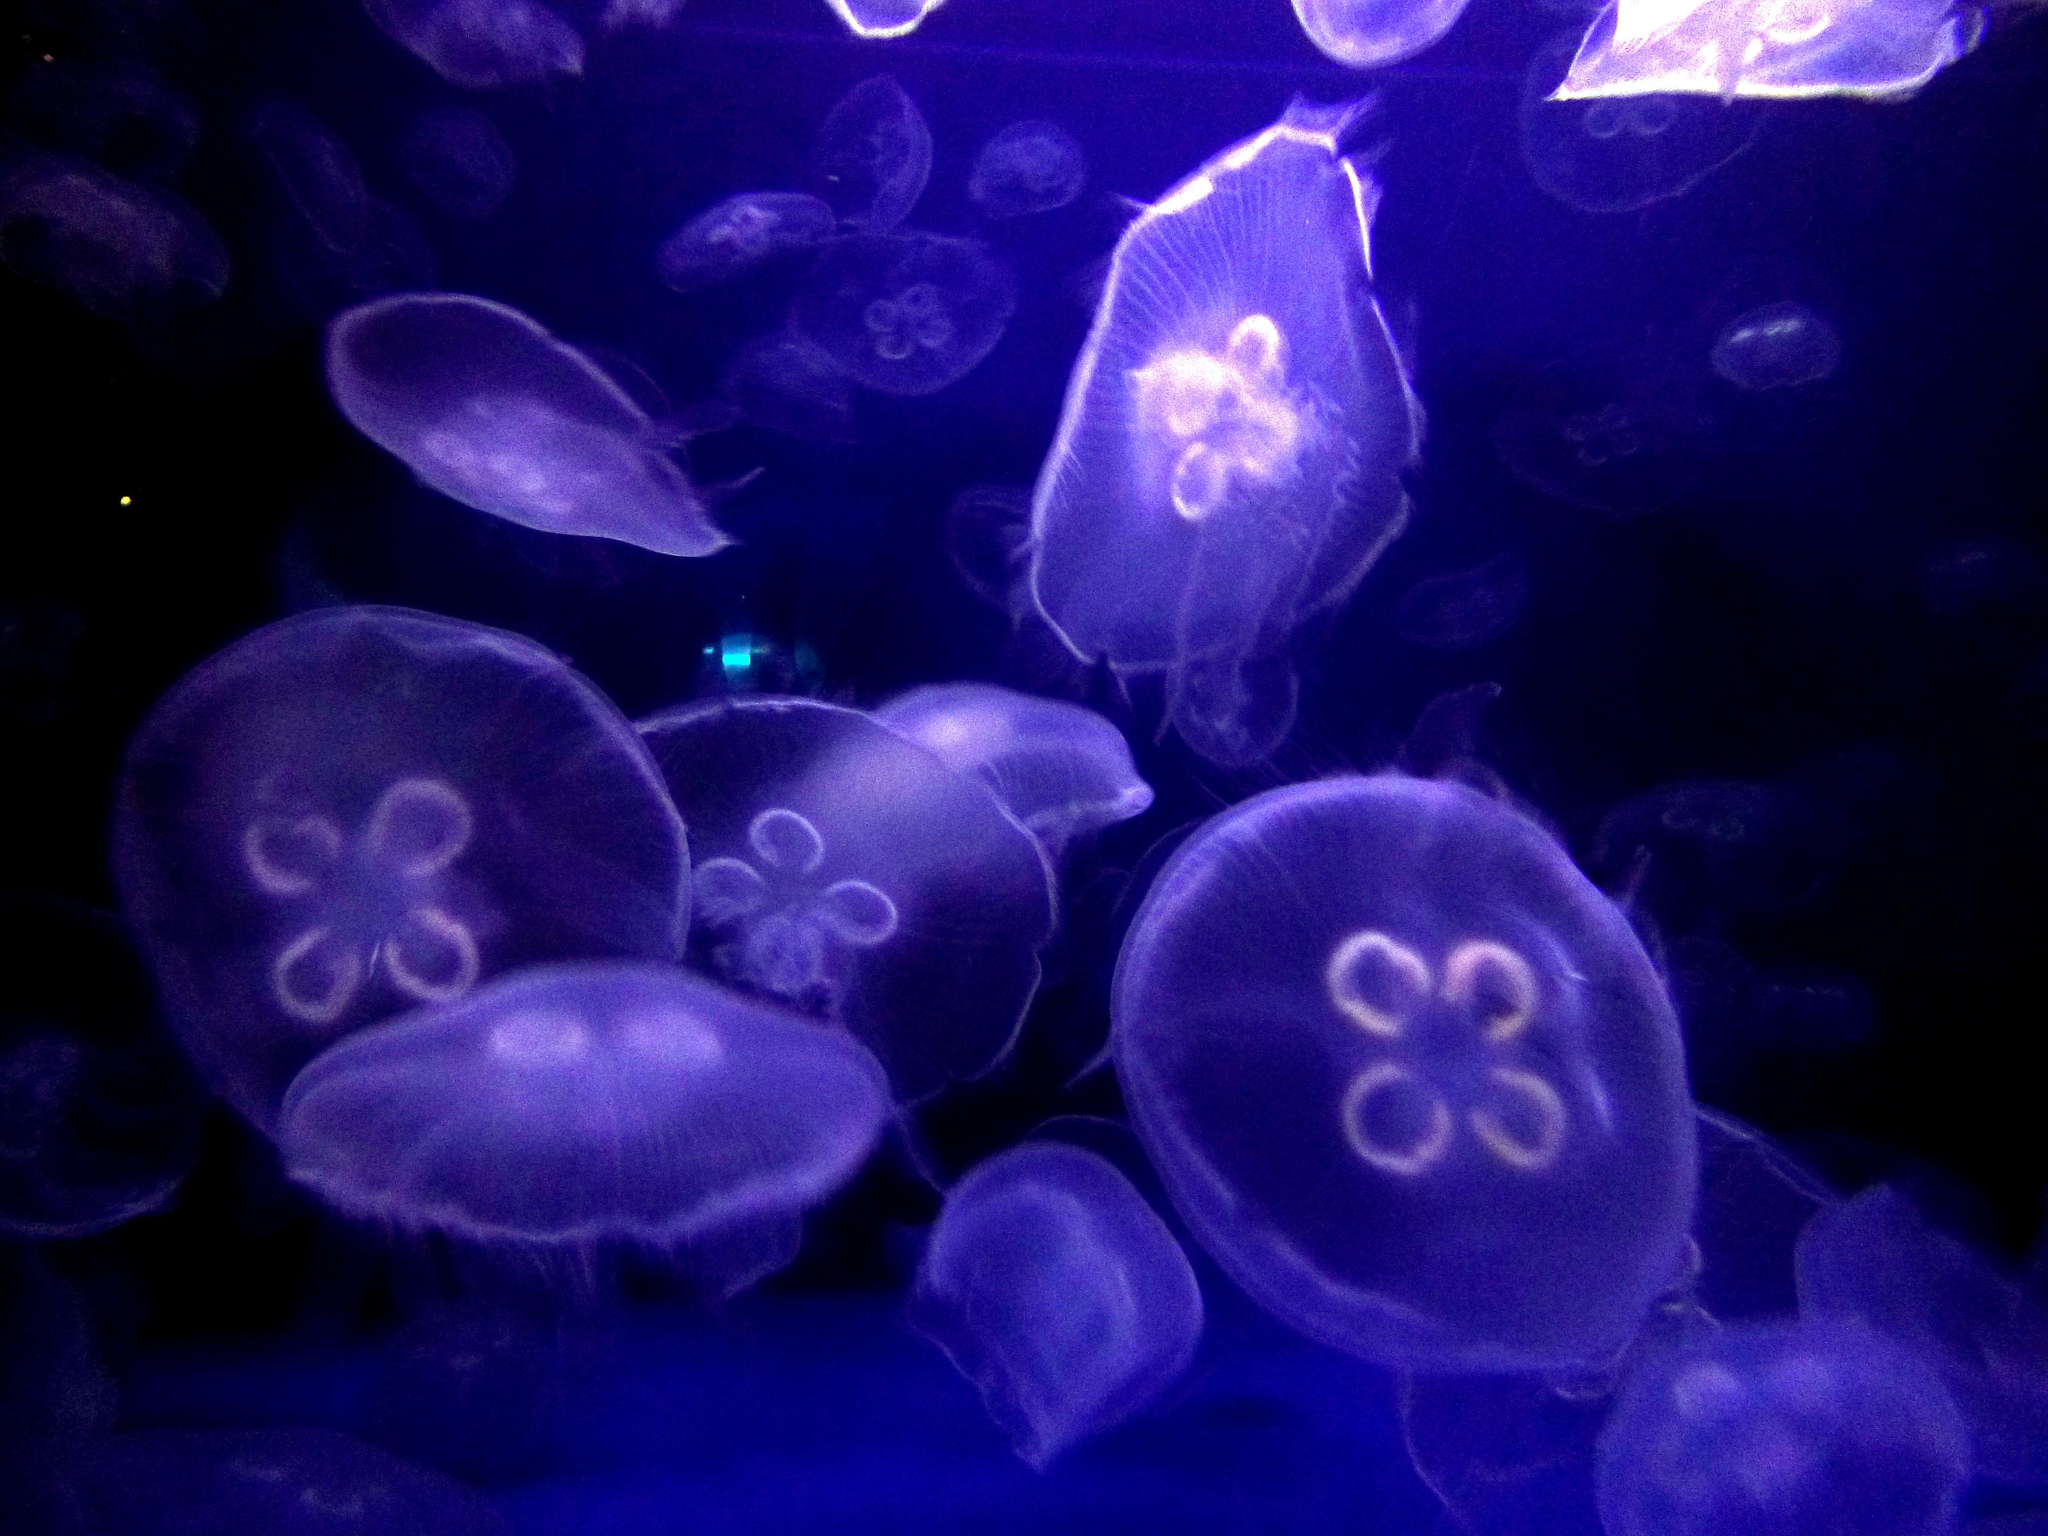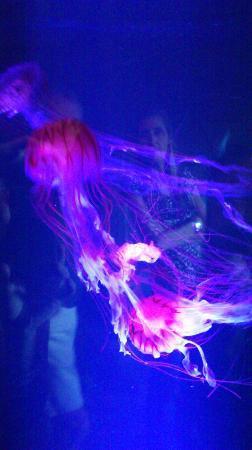The first image is the image on the left, the second image is the image on the right. Examine the images to the left and right. Is the description "Both images contain Moon Jelly jellyfish." accurate? Answer yes or no. No. The first image is the image on the left, the second image is the image on the right. Given the left and right images, does the statement "There area at least 10 jellyfish in the water and at least two with a clover looking inside facing forward lite in pink and blue." hold true? Answer yes or no. Yes. 